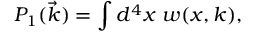Convert formula to latex. <formula><loc_0><loc_0><loc_500><loc_500>P _ { 1 } ( \vec { k } ) = \int d ^ { 4 } x \ w ( x , k ) ,</formula> 